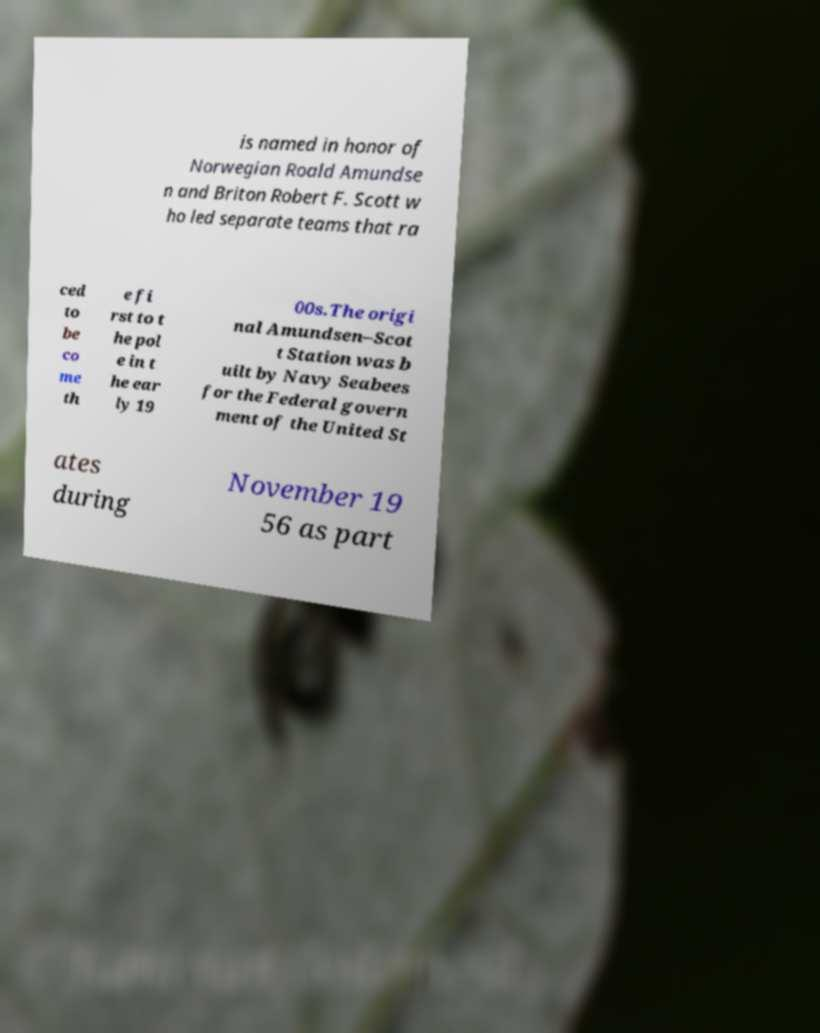Could you assist in decoding the text presented in this image and type it out clearly? is named in honor of Norwegian Roald Amundse n and Briton Robert F. Scott w ho led separate teams that ra ced to be co me th e fi rst to t he pol e in t he ear ly 19 00s.The origi nal Amundsen–Scot t Station was b uilt by Navy Seabees for the Federal govern ment of the United St ates during November 19 56 as part 